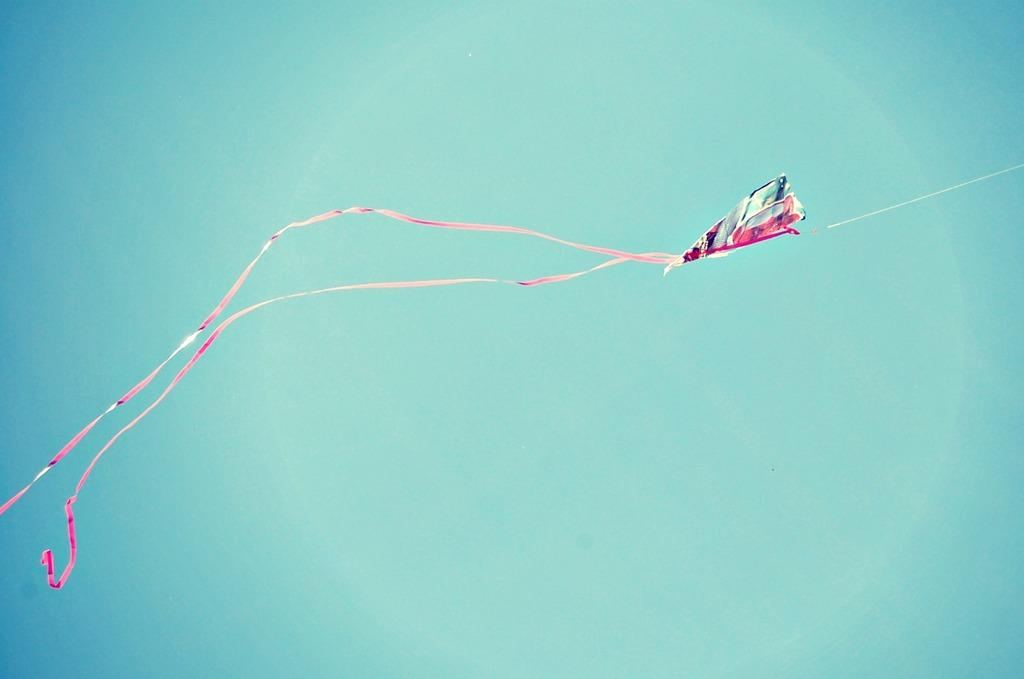What can be seen at the top of the image? The sky is visible in the image. What object is located in the middle of the image? There is a kite visible in the middle of the image. What type of servant is shown in the image? There is no servant present in the image; it only features the sky and a kite. Is it raining in the image? There is no indication of rain in the image; only the sky and a kite are visible. 